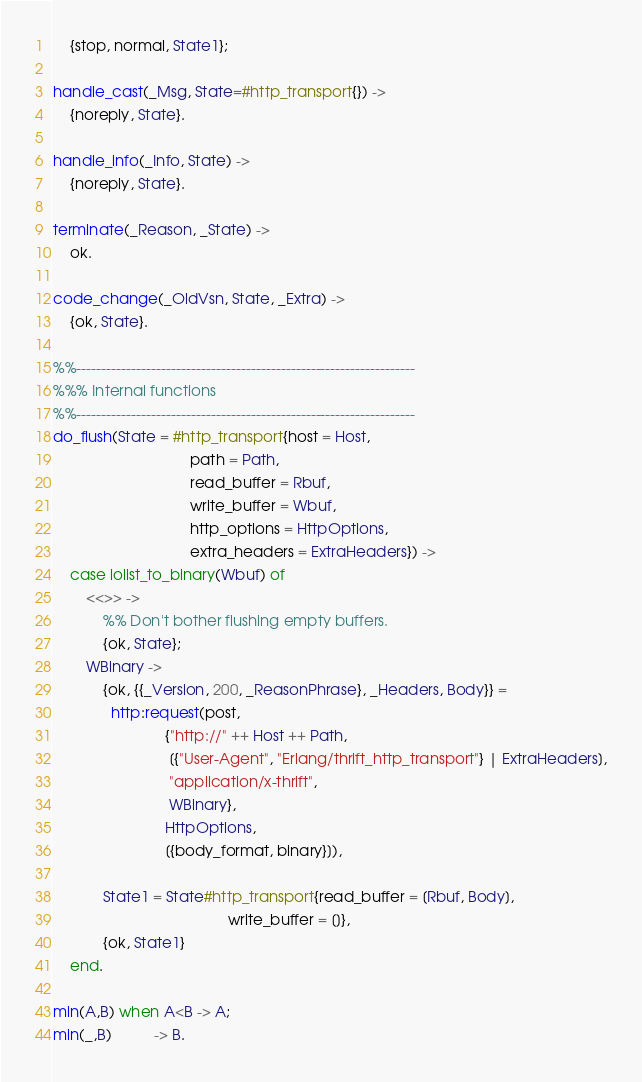<code> <loc_0><loc_0><loc_500><loc_500><_Erlang_>    {stop, normal, State1};

handle_cast(_Msg, State=#http_transport{}) ->
    {noreply, State}.

handle_info(_Info, State) ->
    {noreply, State}.

terminate(_Reason, _State) ->
    ok.

code_change(_OldVsn, State, _Extra) ->
    {ok, State}.

%%--------------------------------------------------------------------
%%% Internal functions
%%--------------------------------------------------------------------
do_flush(State = #http_transport{host = Host,
                                 path = Path,
                                 read_buffer = Rbuf,
                                 write_buffer = Wbuf,
                                 http_options = HttpOptions,
                                 extra_headers = ExtraHeaders}) ->
    case iolist_to_binary(Wbuf) of
        <<>> ->
            %% Don't bother flushing empty buffers.
            {ok, State};
        WBinary ->
            {ok, {{_Version, 200, _ReasonPhrase}, _Headers, Body}} =
              http:request(post,
                           {"http://" ++ Host ++ Path,
                            [{"User-Agent", "Erlang/thrift_http_transport"} | ExtraHeaders],
                            "application/x-thrift",
                            WBinary},
                           HttpOptions,
                           [{body_format, binary}]),

            State1 = State#http_transport{read_buffer = [Rbuf, Body],
                                          write_buffer = []},
            {ok, State1}
    end.

min(A,B) when A<B -> A;
min(_,B)          -> B.
</code> 